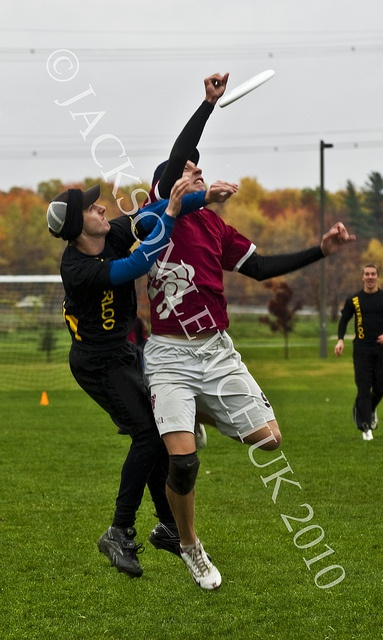Describe the objects in this image and their specific colors. I can see people in lightgray, black, darkgray, and maroon tones, people in lightgray, black, olive, navy, and gray tones, people in lightgray, black, olive, brown, and maroon tones, and frisbee in lightgray, white, darkgray, and gray tones in this image. 